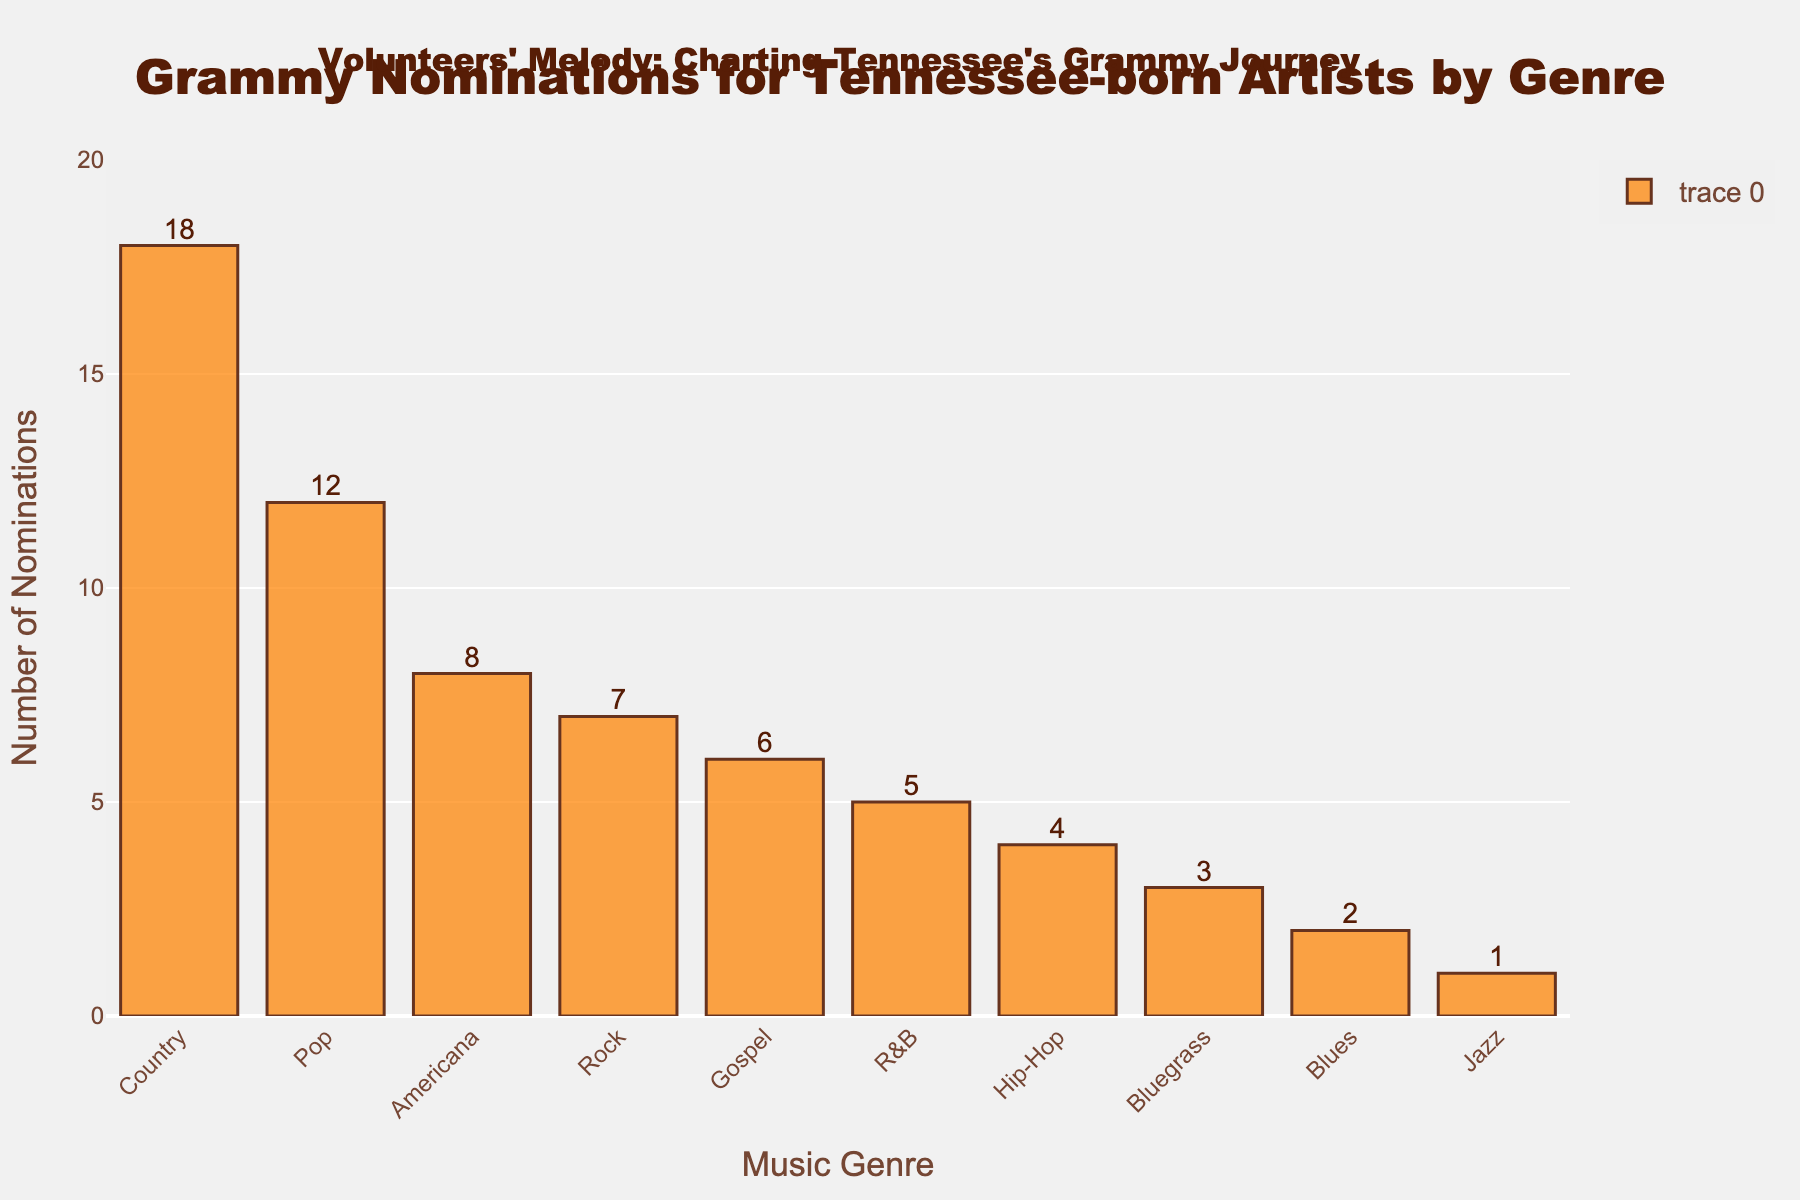What's the most nominated genre? Check the bar heights and find the bar with the highest height. Country has the highest number of nominations at 18.
Answer: Country Which genre has the least nominations? Identify the bar with the lowest height. Jazz has the least number of nominations at 1.
Answer: Jazz How many more nominations does Country have compared to Rock? Find the difference in heights of the Country and Rock bars. Country has 18 nominations and Rock has 7, so 18 - 7 = 11.
Answer: 11 What is the total number of nominations for Pop and Hip-Hop combined? Add the heights of the Pop and Hip-Hop bars. Pop has 12, and Hip-Hop has 4. So, 12 + 4 = 16.
Answer: 16 What is the average number of nominations for the top 3 most nominated genres? Identify the top 3 genres (Country, Pop, Americana), then sum and divide by 3. Country has 18, Pop has 12, and Americana has 8. (18 + 12 + 8) / 3 = 38 / 3 ≈ 12.67.
Answer: 12.67 Which genres have fewer nominations than R&B? Compare the height of the R&B bar (5) with others. Genres with fewer nominations are Blues (2), Jazz (1), Bluegrass (3), and Hip-Hop (4).
Answer: Blues, Jazz, Bluegrass, Hip-Hop How many genres have nominations between 5 and 10 (inclusive)? Count the bars with heights within the range 5 to 10. R&B (5), Gospel (6), Rock (7), and Americana (8) fall into this category. There are 4 such genres.
Answer: 4 By how many nominations does Americana exceed Bluegrass? Find the difference in the heights of the Americana and Bluegrass bars. Americana has 8, and Bluegrass has 3, so 8 - 3 = 5.
Answer: 5 What percentage of the total nominations does Country represent? Sum all the nomination values and calculate the percentage for Country. Total nominations = 18+12+7+5+4+6+3+8+2+1 = 66. Percentage for Country = (18 / 66) * 100 ≈ 27.27%.
Answer: 27.27% Which genre has a single-digit number of nominations but more nominations than Jazz? Identify genres with nominations from 1-9 that are greater than Jazz's 1 nomination. Genres that fit this are Bluegrass (3), and Blues (2).
Answer: Bluegrass, Blues 